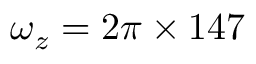<formula> <loc_0><loc_0><loc_500><loc_500>\omega _ { z } = 2 \pi \times 1 4 7</formula> 